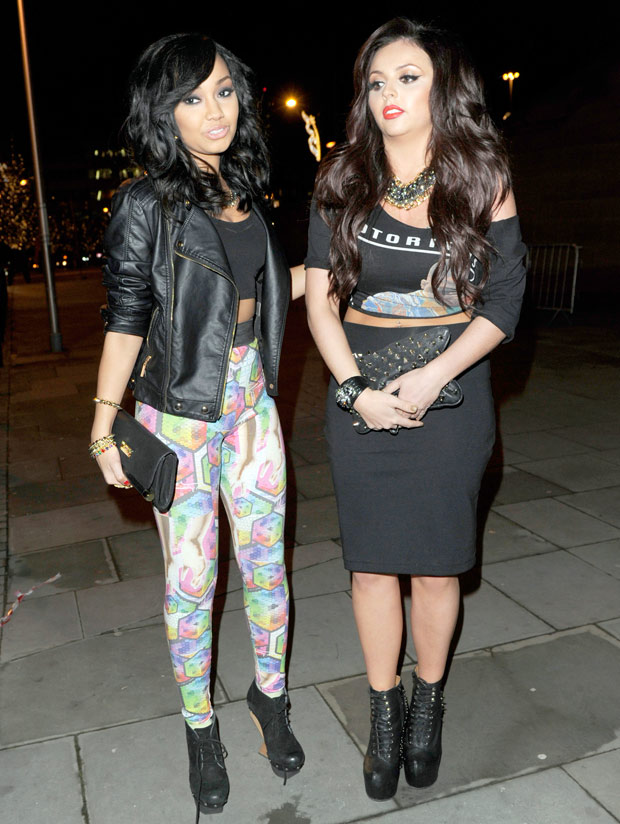What challenges might they face in this urban setting at night? In this urban setting at night, they might face various challenges. One could be navigating through crowded areas filled with late-night revelers, ensuring they stay safe and stick together. They might encounter unfamiliar or dimly lit streets that could pose safety risks, prompting them to stay alert and aware of their surroundings. They could also face sudden changes in weather, such as unexpected rain, affecting their plans for the evening. Additionally, they might confront social challenges, such as dealing with unwelcome advances or aggressive behavior from strangers, necessitating quick thinking and confidence to handle such situations. Can you describe their possible night explicitly and in detail? Their night begins as they step out of their chic apartment onto the bustling streets, where the city's pulsating nightlife awaits. The air is filled with anticipation, a symphony of distant music and laughter blending with the hum of traffic and the crisp night breeze. They decide to start their evening at an upscale rooftop bar, known for its breathtaking panoramic views of the city skyline. As they take the elevator up, their excitement builds. Once at the top, they're greeted with a stunning view: the city glistening like a sea of stars under the night sky. They order signature cocktails, each sip a blend of exotic flavors that tantalize their taste buds. They chat animatedly, the conversation flowing effortlessly as they catch up on the week's events. The vibrant atmosphere of the bar, filled with well-dressed patrons and the soft glow of ambient lighting, sets the perfect tone for their night. After an hour, they decide to move on to a popular nightclub famous for its electrifying music and dynamic dance floor. They hail a taxi, the driver engaging them in friendly banter as they weave through the shimmering streets. Arriving at the club, they are greeted by the pulsating beat of the latest hits and the excited buzz of party-goers. Inside, they lose themselves in the music, dancing with abandon, their outfits sparkling under the strobe lights. They share joyous moments, hopping to the rhythm, feeling the collective energy of the crowd. Hours fly by as they transition from one song to the next. Finally, as the night winds down, they decide to grab a bite from a nearby 24-hour diner. The contrast between the lively club and the cozy, quiet diner offers a welcome reprieve. They enjoy comfort food, reminiscing about the night's highlights, still wearing smiles from their unforgettable experiences. As they stroll back home under the early hints of dawn, they reflect on a night well spent, filled with laughter, adventure, and the effervescent charm of the city's nightlife. 